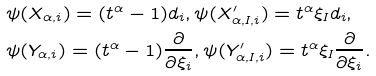Convert formula to latex. <formula><loc_0><loc_0><loc_500><loc_500>& \psi ( X _ { \alpha , i } ) = ( t ^ { \alpha } - 1 ) d _ { i } , \psi ( X ^ { \prime } _ { \alpha , I , i } ) = t ^ { \alpha } \xi _ { I } d _ { i } , \\ & \psi ( Y _ { \alpha , i } ) = ( t ^ { \alpha } - 1 ) \frac { \partial } { \partial \xi _ { i } } , \psi ( Y ^ { \prime } _ { \alpha , I , i } ) = t ^ { \alpha } \xi _ { I } \frac { \partial } { \partial \xi _ { i } } .</formula> 